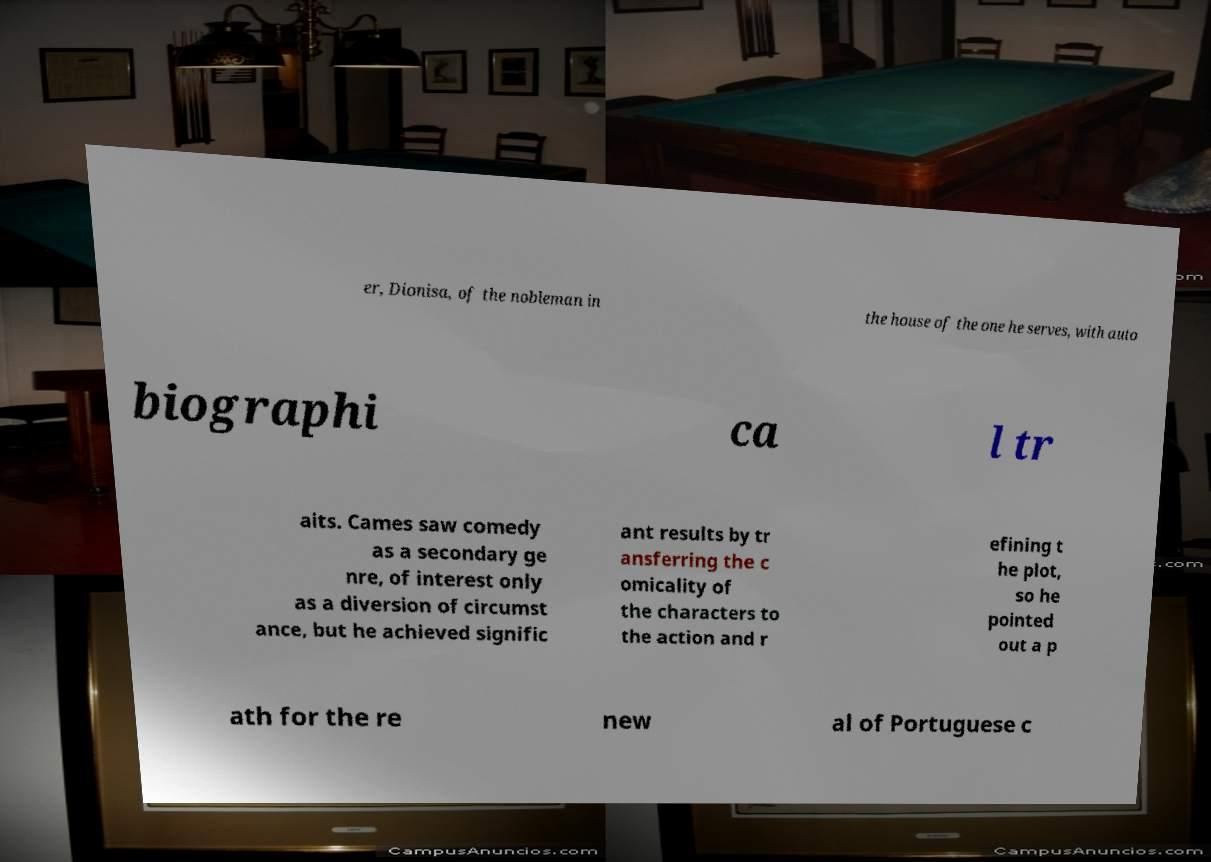Can you accurately transcribe the text from the provided image for me? er, Dionisa, of the nobleman in the house of the one he serves, with auto biographi ca l tr aits. Cames saw comedy as a secondary ge nre, of interest only as a diversion of circumst ance, but he achieved signific ant results by tr ansferring the c omicality of the characters to the action and r efining t he plot, so he pointed out a p ath for the re new al of Portuguese c 